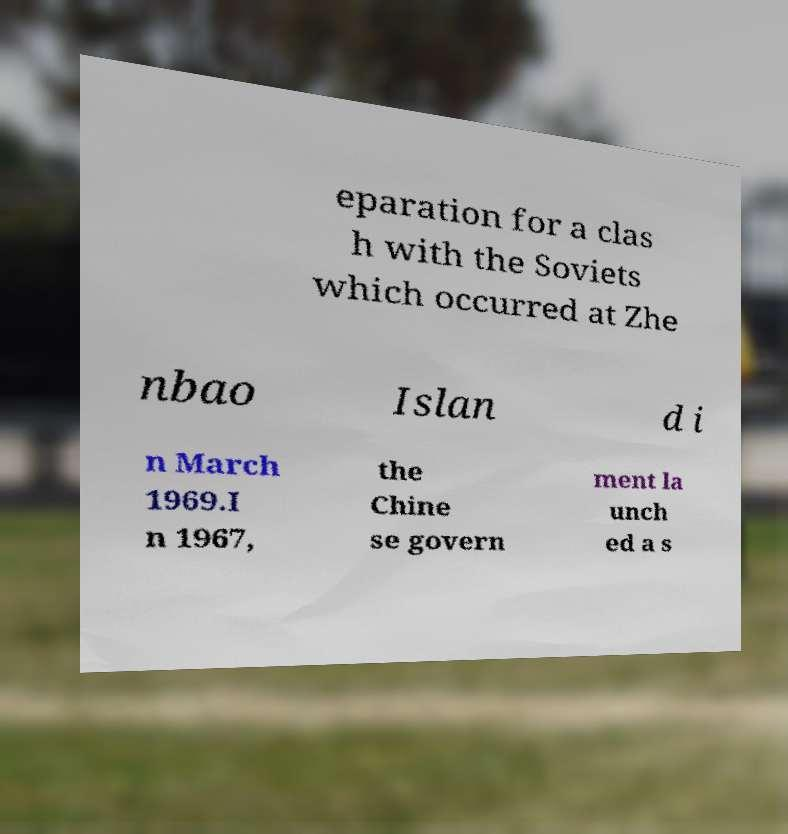Can you read and provide the text displayed in the image?This photo seems to have some interesting text. Can you extract and type it out for me? eparation for a clas h with the Soviets which occurred at Zhe nbao Islan d i n March 1969.I n 1967, the Chine se govern ment la unch ed a s 